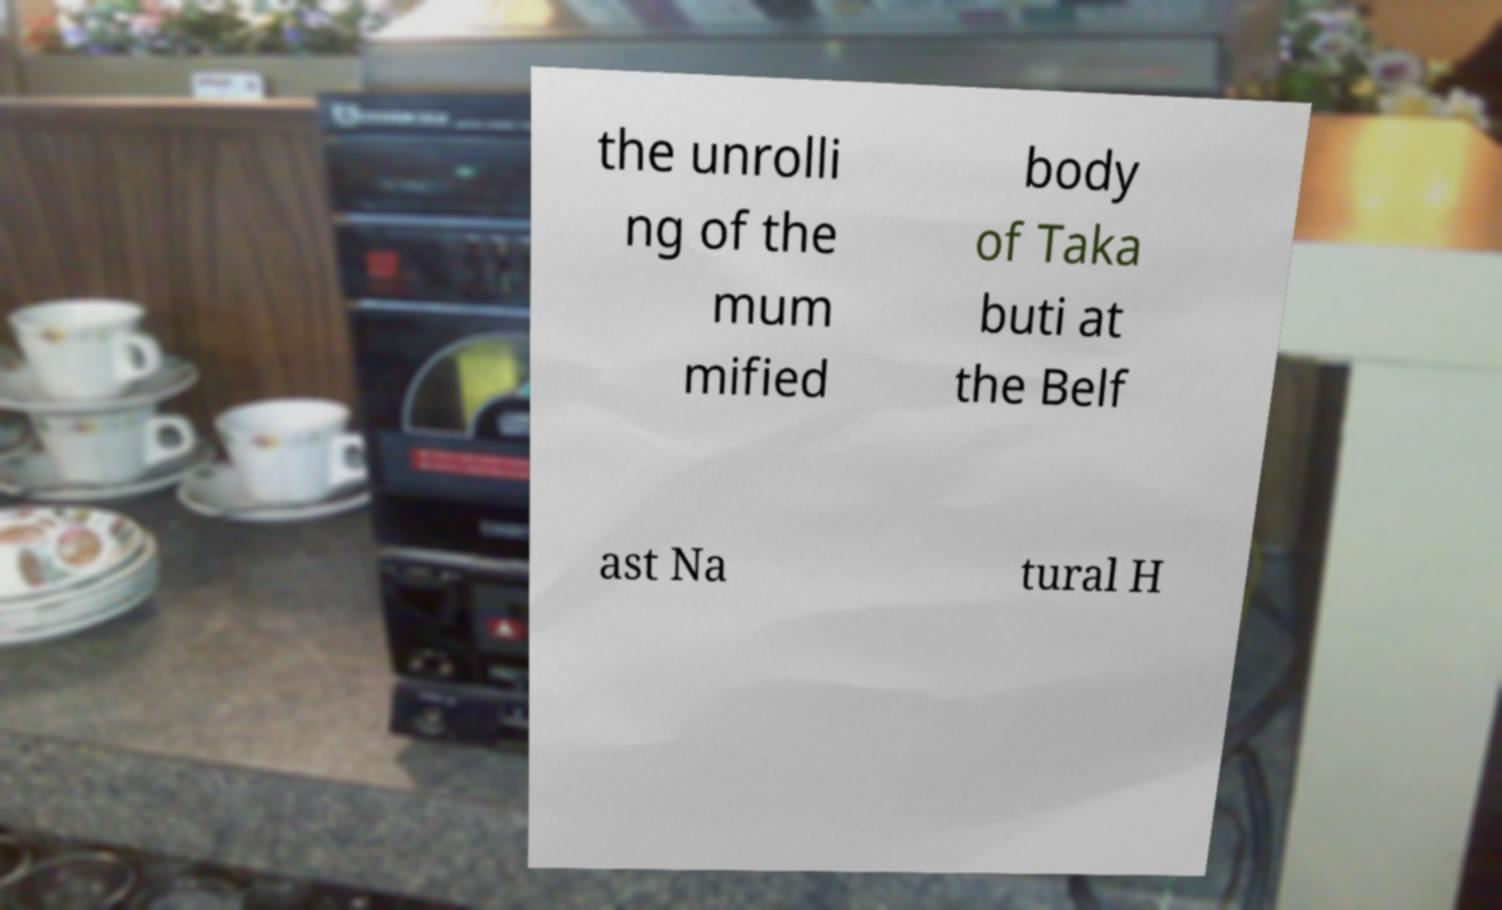Could you extract and type out the text from this image? the unrolli ng of the mum mified body of Taka buti at the Belf ast Na tural H 